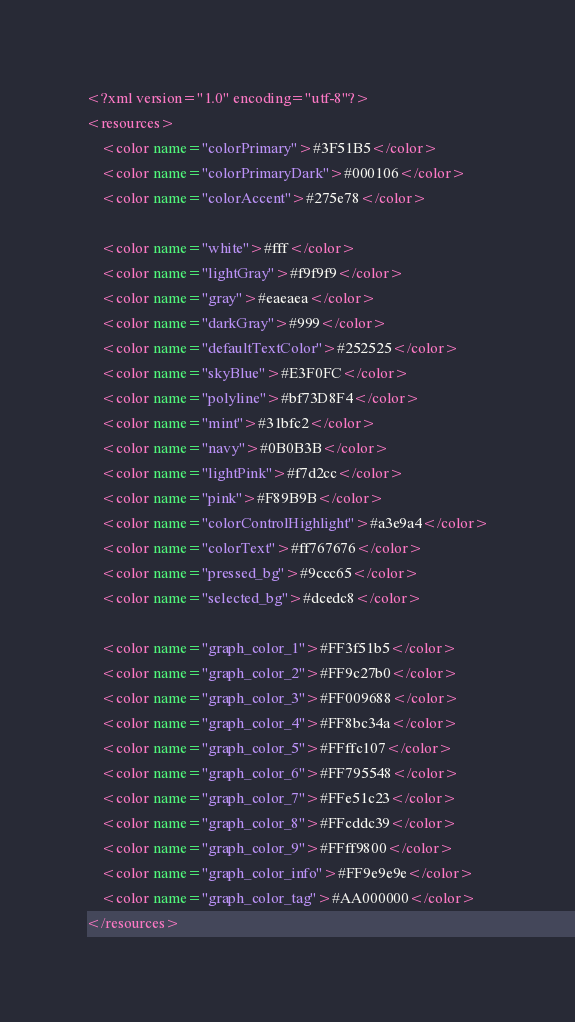<code> <loc_0><loc_0><loc_500><loc_500><_XML_><?xml version="1.0" encoding="utf-8"?>
<resources>
    <color name="colorPrimary">#3F51B5</color>
    <color name="colorPrimaryDark">#000106</color>
    <color name="colorAccent">#275e78</color>

    <color name="white">#fff</color>
    <color name="lightGray">#f9f9f9</color>
    <color name="gray">#eaeaea</color>
    <color name="darkGray">#999</color>
    <color name="defaultTextColor">#252525</color>
    <color name="skyBlue">#E3F0FC</color>
    <color name="polyline">#bf73D8F4</color>
    <color name="mint">#31bfc2</color>
    <color name="navy">#0B0B3B</color>
    <color name="lightPink">#f7d2cc</color>
    <color name="pink">#F89B9B</color>
    <color name="colorControlHighlight">#a3e9a4</color>
    <color name="colorText">#ff767676</color>
    <color name="pressed_bg">#9ccc65</color>
    <color name="selected_bg">#dcedc8</color>

    <color name="graph_color_1">#FF3f51b5</color>
    <color name="graph_color_2">#FF9c27b0</color>
    <color name="graph_color_3">#FF009688</color>
    <color name="graph_color_4">#FF8bc34a</color>
    <color name="graph_color_5">#FFffc107</color>
    <color name="graph_color_6">#FF795548</color>
    <color name="graph_color_7">#FFe51c23</color>
    <color name="graph_color_8">#FFcddc39</color>
    <color name="graph_color_9">#FFff9800</color>
    <color name="graph_color_info">#FF9e9e9e</color>
    <color name="graph_color_tag">#AA000000</color>
</resources></code> 